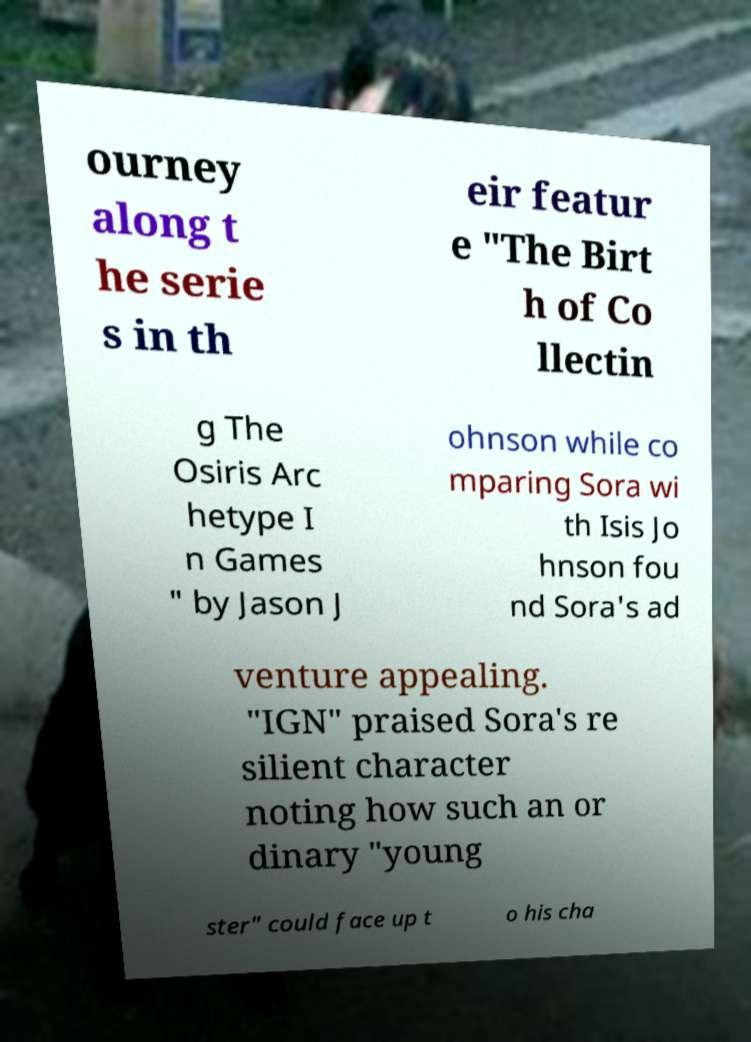What messages or text are displayed in this image? I need them in a readable, typed format. ourney along t he serie s in th eir featur e "The Birt h of Co llectin g The Osiris Arc hetype I n Games " by Jason J ohnson while co mparing Sora wi th Isis Jo hnson fou nd Sora's ad venture appealing. "IGN" praised Sora's re silient character noting how such an or dinary "young ster" could face up t o his cha 